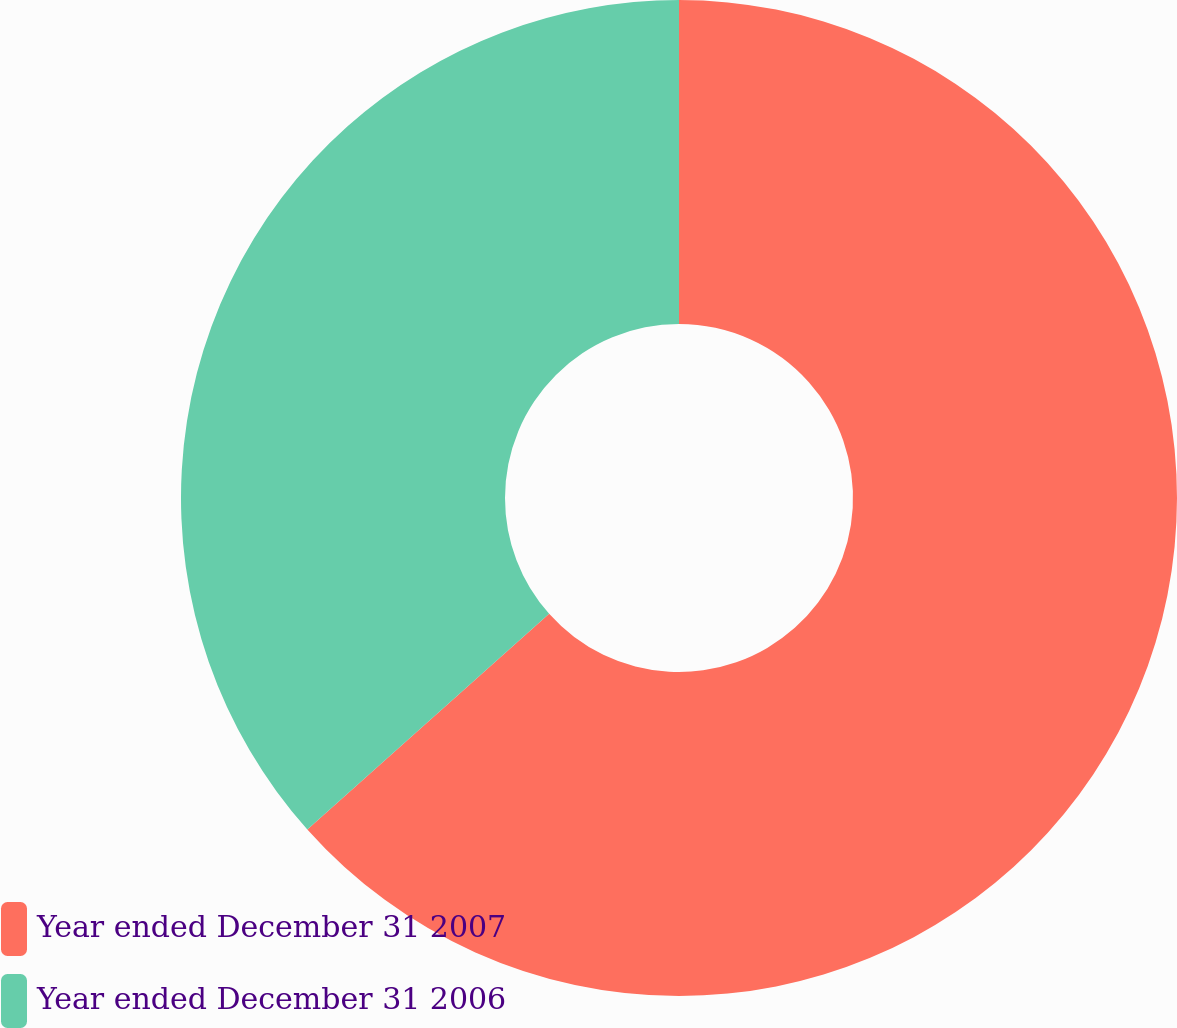Convert chart to OTSL. <chart><loc_0><loc_0><loc_500><loc_500><pie_chart><fcel>Year ended December 31 2007<fcel>Year ended December 31 2006<nl><fcel>63.41%<fcel>36.59%<nl></chart> 